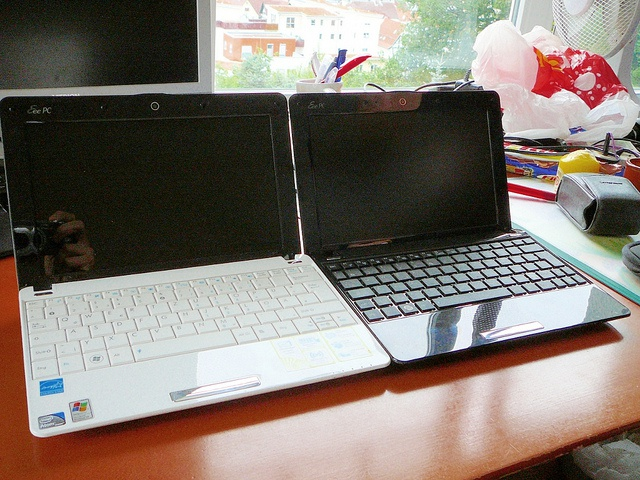Describe the objects in this image and their specific colors. I can see laptop in black, lightgray, and darkgray tones and laptop in black, lightgray, darkgray, and gray tones in this image. 